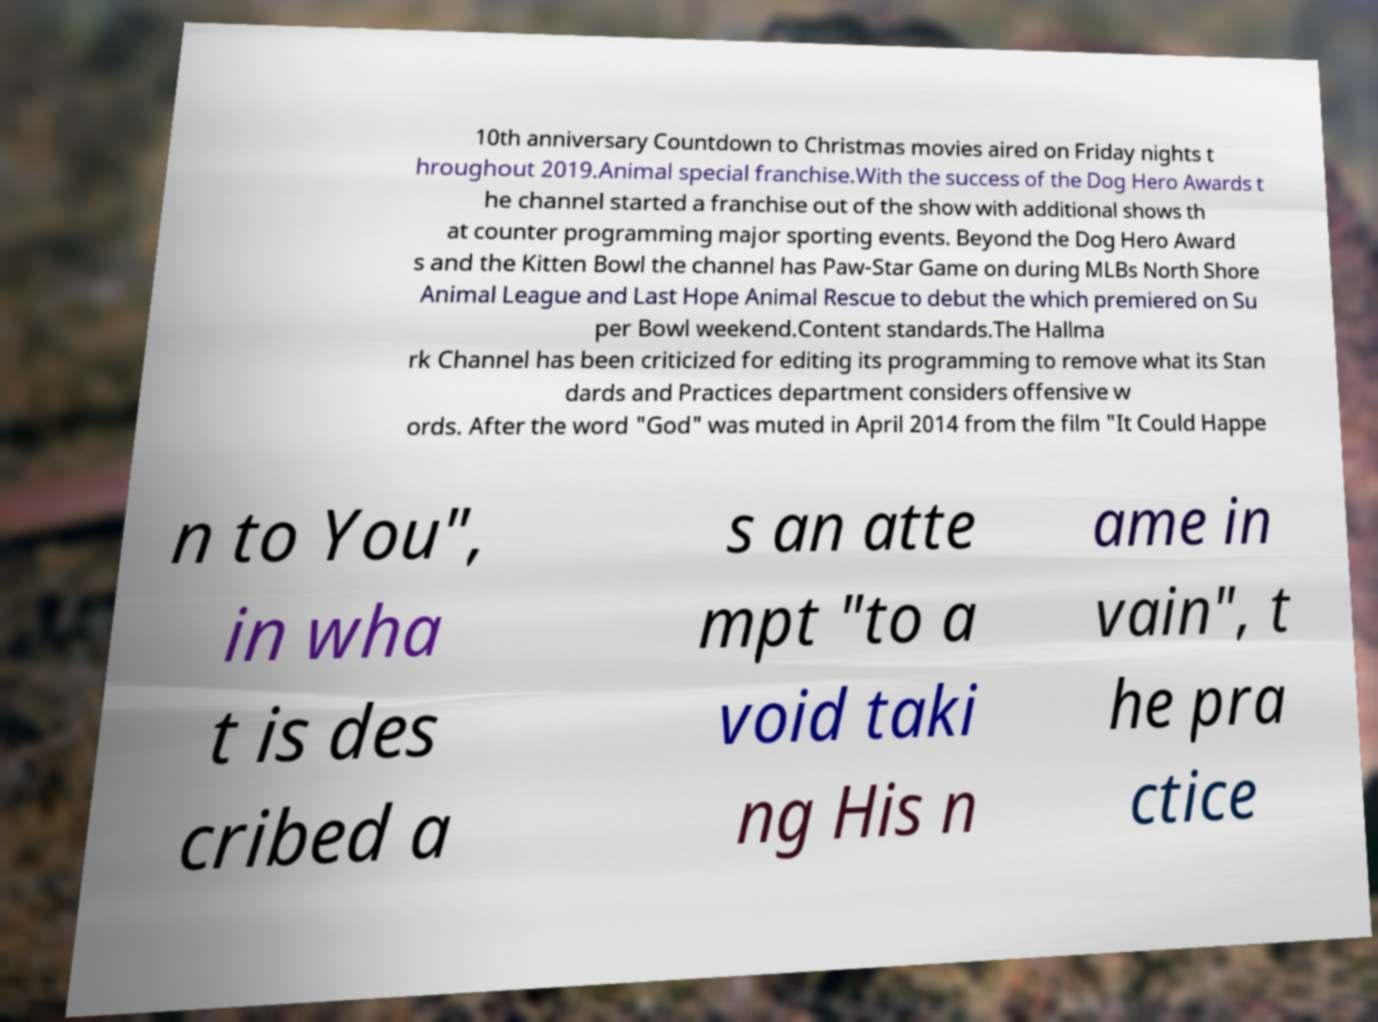Please read and relay the text visible in this image. What does it say? 10th anniversary Countdown to Christmas movies aired on Friday nights t hroughout 2019.Animal special franchise.With the success of the Dog Hero Awards t he channel started a franchise out of the show with additional shows th at counter programming major sporting events. Beyond the Dog Hero Award s and the Kitten Bowl the channel has Paw-Star Game on during MLBs North Shore Animal League and Last Hope Animal Rescue to debut the which premiered on Su per Bowl weekend.Content standards.The Hallma rk Channel has been criticized for editing its programming to remove what its Stan dards and Practices department considers offensive w ords. After the word "God" was muted in April 2014 from the film "It Could Happe n to You", in wha t is des cribed a s an atte mpt "to a void taki ng His n ame in vain", t he pra ctice 